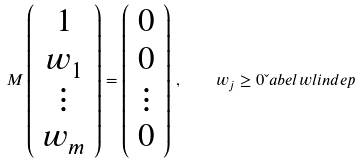Convert formula to latex. <formula><loc_0><loc_0><loc_500><loc_500>M \left ( \begin{array} { c } 1 \\ w _ { 1 } \\ \vdots \\ w _ { m } \end{array} \right ) = \left ( \begin{array} { c } 0 \\ 0 \\ \vdots \\ 0 \end{array} \right ) \, , \quad w _ { j } \geq 0 \L a b e l { w l i n d e p }</formula> 